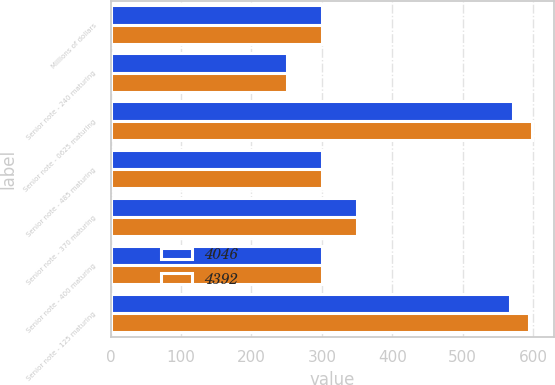Convert chart. <chart><loc_0><loc_0><loc_500><loc_500><stacked_bar_chart><ecel><fcel>Millions of dollars<fcel>Senior note - 240 maturing<fcel>Senior note - 0625 maturing<fcel>Senior note - 485 maturing<fcel>Senior note - 370 maturing<fcel>Senior note - 400 maturing<fcel>Senior note - 125 maturing<nl><fcel>4046<fcel>300<fcel>250<fcel>572<fcel>300<fcel>350<fcel>300<fcel>567<nl><fcel>4392<fcel>300<fcel>250<fcel>599<fcel>300<fcel>350<fcel>300<fcel>594<nl></chart> 